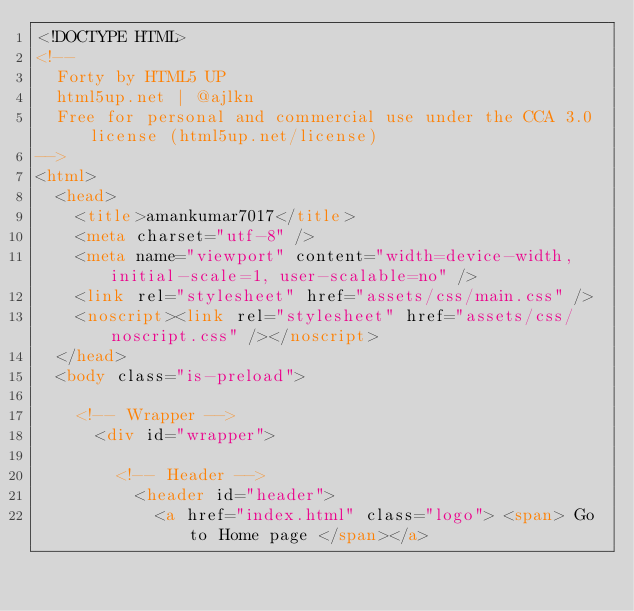<code> <loc_0><loc_0><loc_500><loc_500><_HTML_><!DOCTYPE HTML>
<!--
	Forty by HTML5 UP
	html5up.net | @ajlkn
	Free for personal and commercial use under the CCA 3.0 license (html5up.net/license)
-->
<html>
	<head>
		<title>amankumar7017</title>
		<meta charset="utf-8" />
		<meta name="viewport" content="width=device-width, initial-scale=1, user-scalable=no" />
		<link rel="stylesheet" href="assets/css/main.css" />
		<noscript><link rel="stylesheet" href="assets/css/noscript.css" /></noscript>
	</head>
	<body class="is-preload">

		<!-- Wrapper -->
			<div id="wrapper">

				<!-- Header -->
					<header id="header">
						<a href="index.html" class="logo"> <span> Go to Home page </span></a></code> 